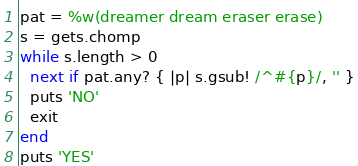Convert code to text. <code><loc_0><loc_0><loc_500><loc_500><_Ruby_>pat = %w(dreamer dream eraser erase)
s = gets.chomp
while s.length > 0
  next if pat.any? { |p| s.gsub! /^#{p}/, '' }
  puts 'NO'
  exit
end
puts 'YES'
</code> 